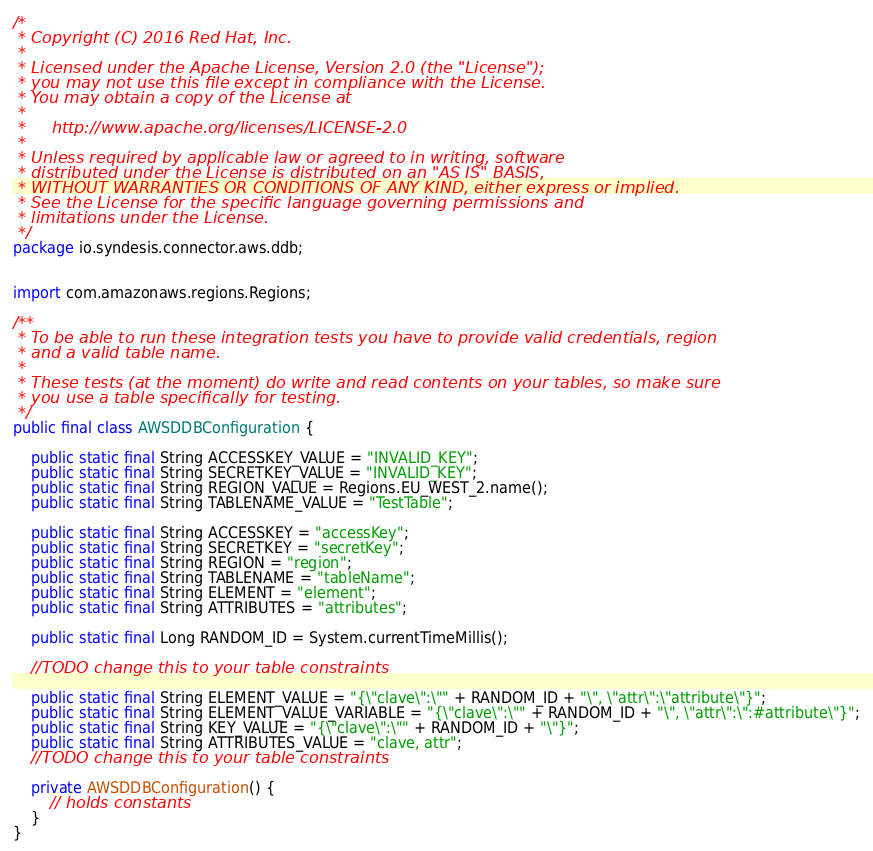<code> <loc_0><loc_0><loc_500><loc_500><_Java_>/*
 * Copyright (C) 2016 Red Hat, Inc.
 *
 * Licensed under the Apache License, Version 2.0 (the "License");
 * you may not use this file except in compliance with the License.
 * You may obtain a copy of the License at
 *
 *     http://www.apache.org/licenses/LICENSE-2.0
 *
 * Unless required by applicable law or agreed to in writing, software
 * distributed under the License is distributed on an "AS IS" BASIS,
 * WITHOUT WARRANTIES OR CONDITIONS OF ANY KIND, either express or implied.
 * See the License for the specific language governing permissions and
 * limitations under the License.
 */
package io.syndesis.connector.aws.ddb;


import com.amazonaws.regions.Regions;

/**
 * To be able to run these integration tests you have to provide valid credentials, region
 * and a valid table name.
 *
 * These tests (at the moment) do write and read contents on your tables, so make sure
 * you use a table specifically for testing.
 */
public final class AWSDDBConfiguration {

    public static final String ACCESSKEY_VALUE = "INVALID_KEY";
    public static final String SECRETKEY_VALUE = "INVALID_KEY";
    public static final String REGION_VALUE = Regions.EU_WEST_2.name();
    public static final String TABLENAME_VALUE = "TestTable";

    public static final String ACCESSKEY = "accessKey";
    public static final String SECRETKEY = "secretKey";
    public static final String REGION = "region";
    public static final String TABLENAME = "tableName";
    public static final String ELEMENT = "element";
    public static final String ATTRIBUTES = "attributes";

    public static final Long RANDOM_ID = System.currentTimeMillis();

    //TODO change this to your table constraints

    public static final String ELEMENT_VALUE = "{\"clave\":\"" + RANDOM_ID + "\", \"attr\":\"attribute\"}";
    public static final String ELEMENT_VALUE_VARIABLE = "{\"clave\":\"" + RANDOM_ID + "\", \"attr\":\":#attribute\"}";
    public static final String KEY_VALUE = "{\"clave\":\"" + RANDOM_ID + "\"}";
    public static final String ATTRIBUTES_VALUE = "clave, attr";
    //TODO change this to your table constraints

    private AWSDDBConfiguration() {
        // holds constants
    }
}
</code> 